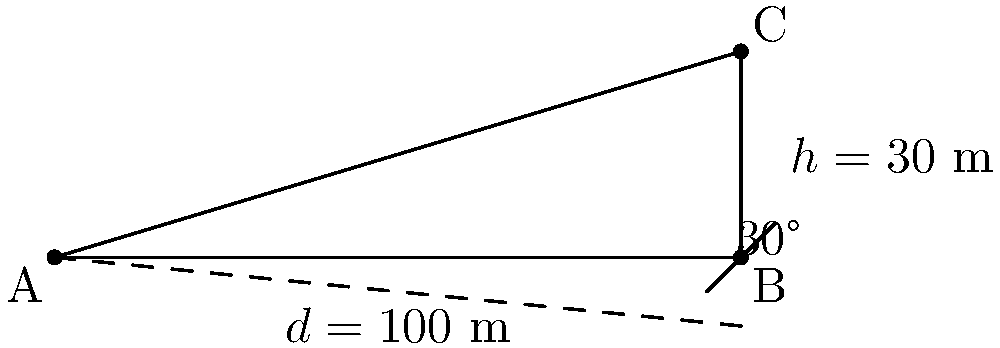During an emergency evacuation, you need to determine the angle of inclination for a safe route down a hillside. The evacuation path covers a horizontal distance of 100 meters and descends 30 meters vertically. What is the angle of inclination of this evacuation route to the nearest degree? To find the angle of inclination, we need to use trigonometry. Let's approach this step-by-step:

1) In this scenario, we have a right-angled triangle where:
   - The adjacent side (horizontal distance) is 100 meters
   - The opposite side (vertical descent) is 30 meters
   - We need to find the angle between the adjacent side and the hypotenuse

2) The tangent of an angle in a right-angled triangle is defined as:

   $\tan(\theta) = \frac{\text{opposite}}{\text{adjacent}}$

3) Substituting our values:

   $\tan(\theta) = \frac{30}{100} = 0.3$

4) To find the angle, we need to use the inverse tangent (arctan or $\tan^{-1}$):

   $\theta = \tan^{-1}(0.3)$

5) Using a calculator or trigonometric tables:

   $\theta \approx 16.70°$

6) Rounding to the nearest degree:

   $\theta \approx 17°$

Therefore, the angle of inclination for the safe evacuation route is approximately 17 degrees.
Answer: 17° 